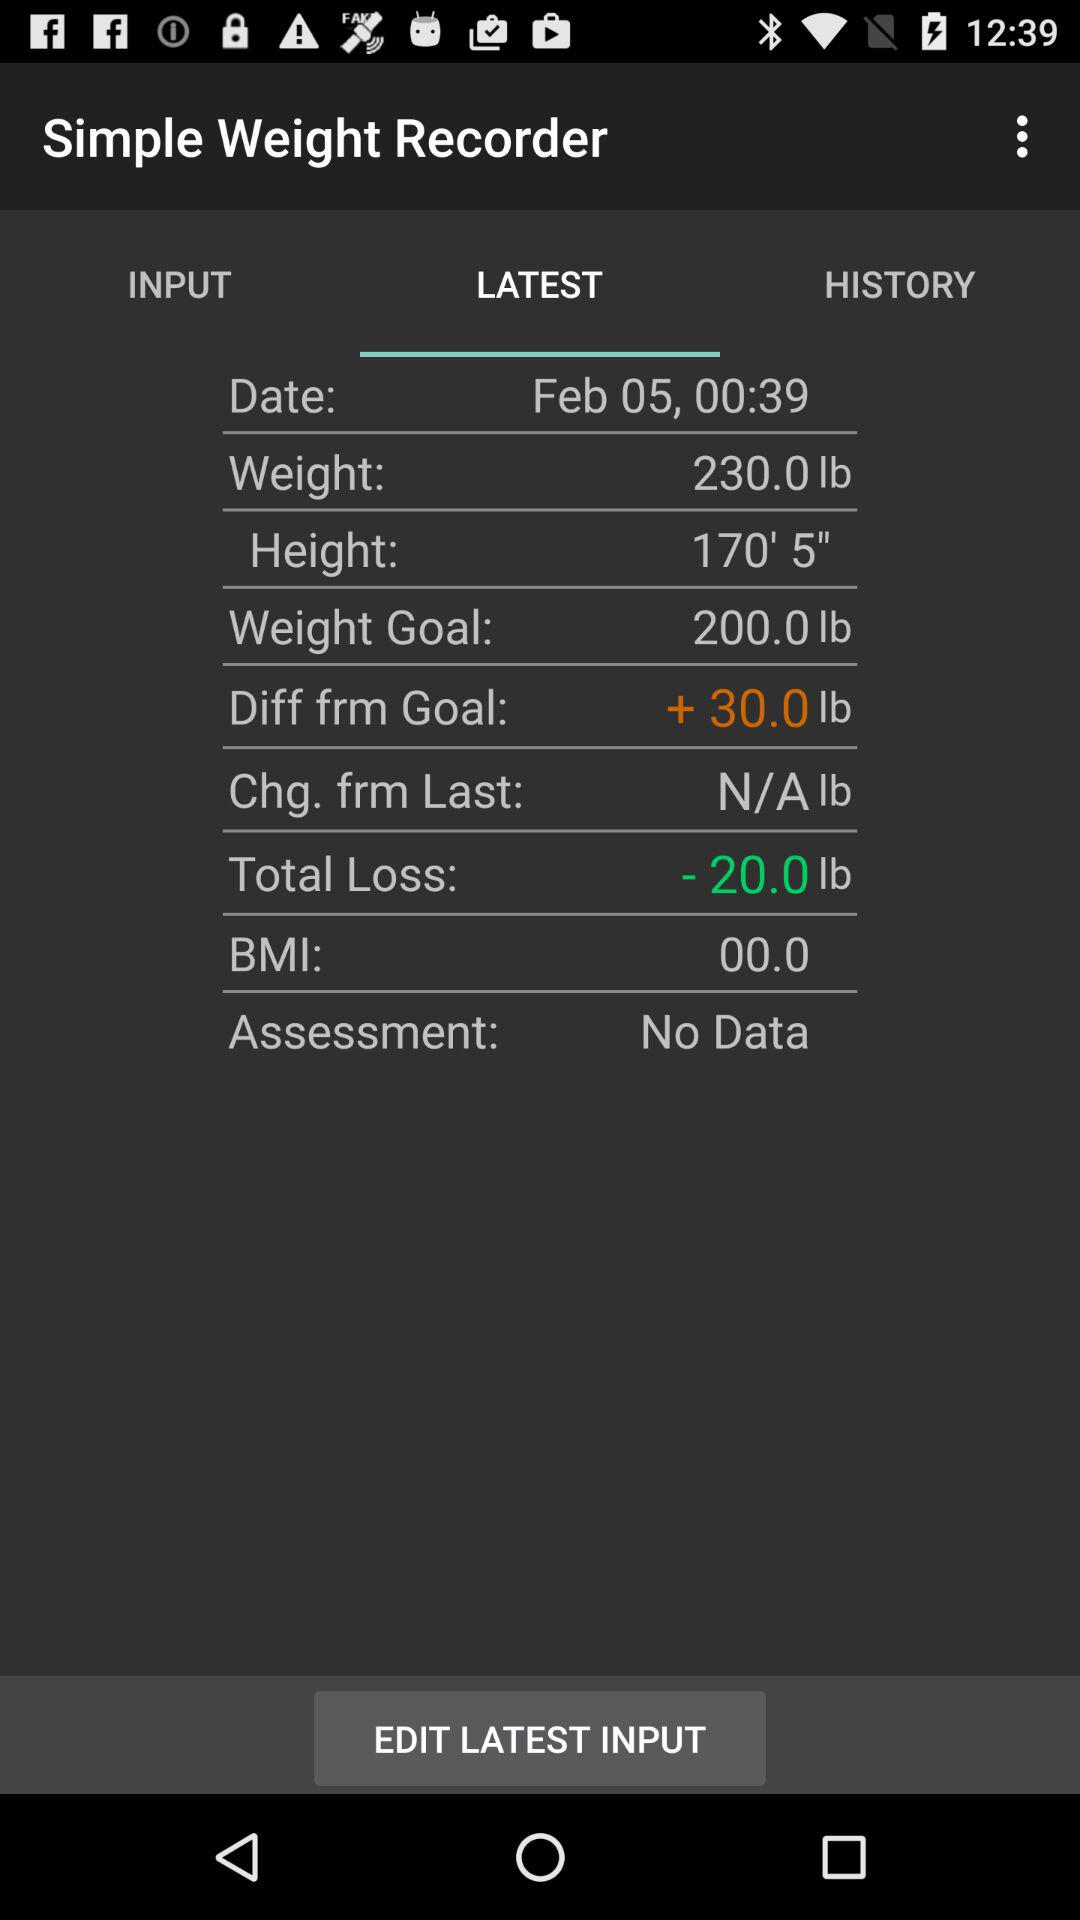What is the date? The date is February 5. 